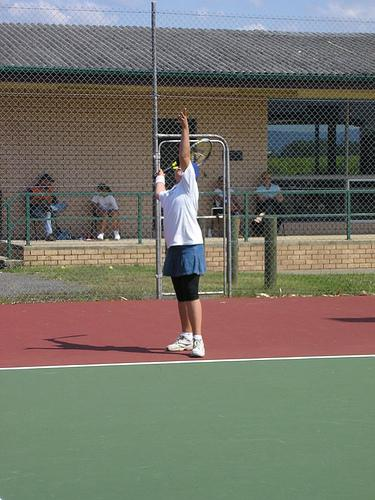Question: who is in this photo?
Choices:
A. A man.
B. A woman.
C. A boy.
D. A tennis player.
Answer with the letter. Answer: D Question: where was this photo taken?
Choices:
A. The tree.
B. The hill.
C. A tennis court.
D. The yard.
Answer with the letter. Answer: C Question: when was this photo taken?
Choices:
A. Yesterday.
B. Today.
C. On a sunny day.
D. Last week.
Answer with the letter. Answer: C Question: how many tennis players are in the photo?
Choices:
A. 2.
B. 4.
C. 1.
D. 6.
Answer with the letter. Answer: C 